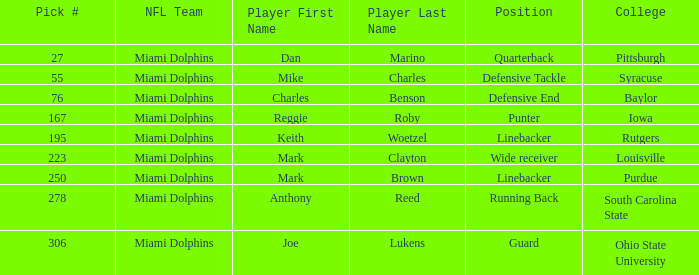Which College has Player Mark Brown and a Pick # greater than 195? Purdue. Give me the full table as a dictionary. {'header': ['Pick #', 'NFL Team', 'Player First Name', 'Player Last Name', 'Position', 'College'], 'rows': [['27', 'Miami Dolphins', 'Dan', 'Marino', 'Quarterback', 'Pittsburgh'], ['55', 'Miami Dolphins', 'Mike', 'Charles', 'Defensive Tackle', 'Syracuse'], ['76', 'Miami Dolphins', 'Charles', 'Benson', 'Defensive End', 'Baylor'], ['167', 'Miami Dolphins', 'Reggie', 'Roby', 'Punter', 'Iowa'], ['195', 'Miami Dolphins', 'Keith', 'Woetzel', 'Linebacker', 'Rutgers'], ['223', 'Miami Dolphins', 'Mark', 'Clayton', 'Wide receiver', 'Louisville'], ['250', 'Miami Dolphins', 'Mark', 'Brown', 'Linebacker', 'Purdue'], ['278', 'Miami Dolphins', 'Anthony', 'Reed', 'Running Back', 'South Carolina State'], ['306', 'Miami Dolphins', 'Joe', 'Lukens', 'Guard', 'Ohio State University']]} 